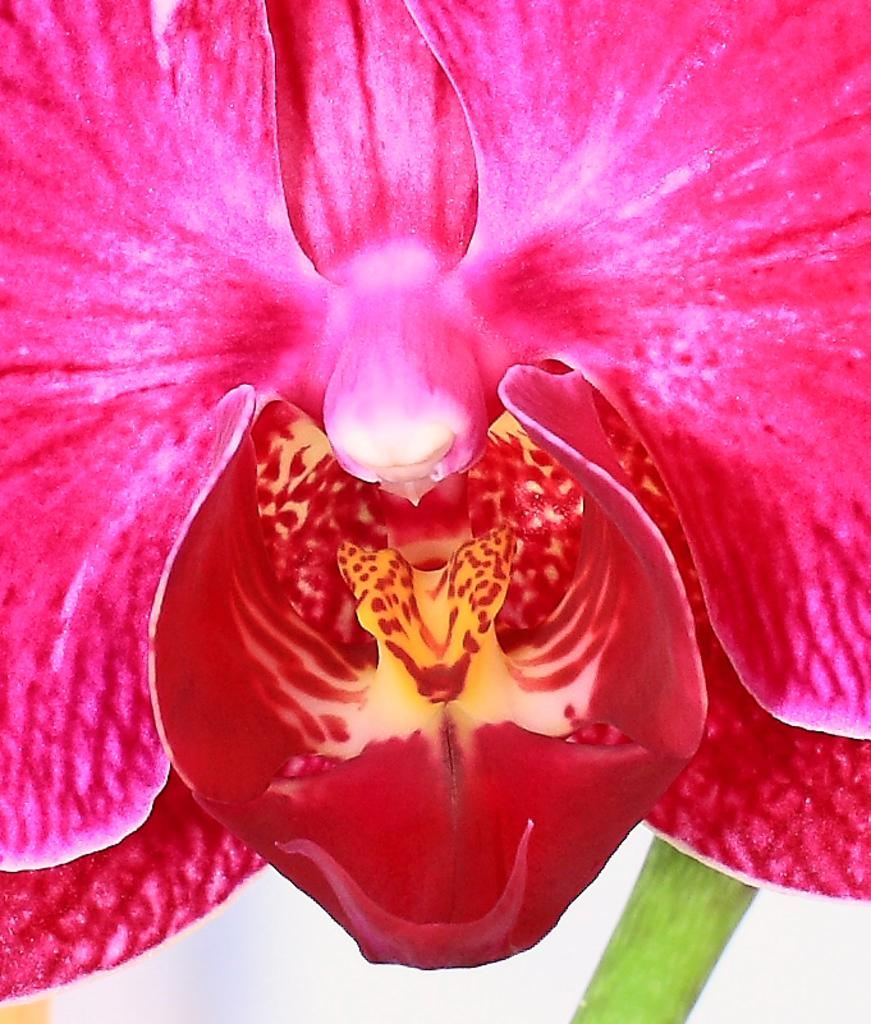What is the main subject of the image? There is a flower in the image. Can you describe any part of the flower? There is a stem associated with the flower. What color is the background of the image? The bottom of the image appears to be white in color. What type of body part can be seen on the man in the image? There is no man present in the image, only a flower and its stem. What is the quince doing in the image? There is no quince present in the image; it features a flower and its stem. 